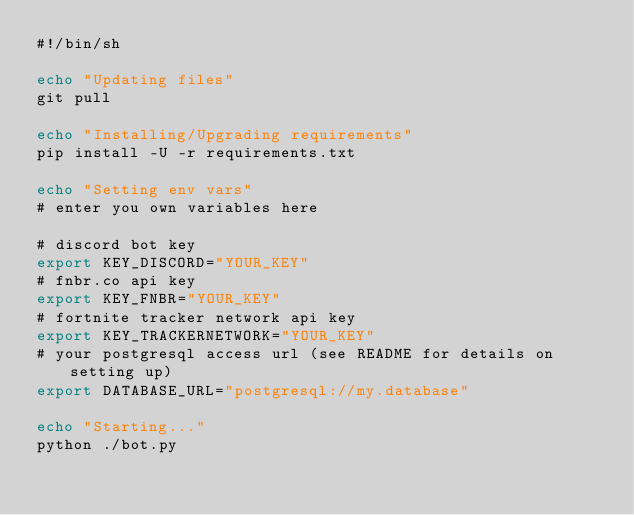<code> <loc_0><loc_0><loc_500><loc_500><_Bash_>#!/bin/sh

echo "Updating files"
git pull

echo "Installing/Upgrading requirements"
pip install -U -r requirements.txt

echo "Setting env vars"
# enter you own variables here

# discord bot key
export KEY_DISCORD="YOUR_KEY"
# fnbr.co api key
export KEY_FNBR="YOUR_KEY"
# fortnite tracker network api key
export KEY_TRACKERNETWORK="YOUR_KEY"
# your postgresql access url (see README for details on setting up)
export DATABASE_URL="postgresql://my.database"

echo "Starting..."
python ./bot.py
</code> 